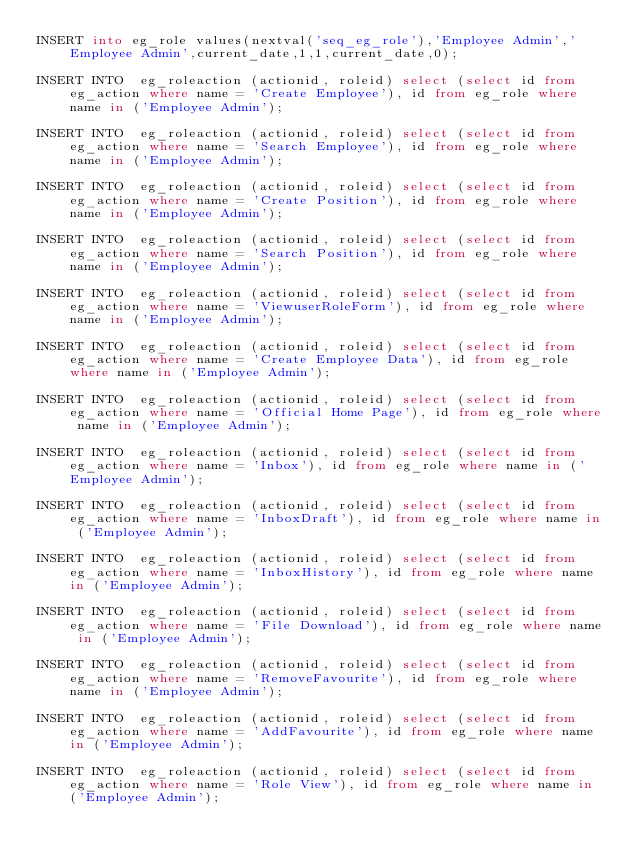<code> <loc_0><loc_0><loc_500><loc_500><_SQL_>INSERT into eg_role values(nextval('seq_eg_role'),'Employee Admin','Employee Admin',current_date,1,1,current_date,0);

INSERT INTO  eg_roleaction (actionid, roleid) select (select id from eg_action where name = 'Create Employee'), id from eg_role where name in ('Employee Admin');

INSERT INTO  eg_roleaction (actionid, roleid) select (select id from eg_action where name = 'Search Employee'), id from eg_role where name in ('Employee Admin');

INSERT INTO  eg_roleaction (actionid, roleid) select (select id from eg_action where name = 'Create Position'), id from eg_role where name in ('Employee Admin');

INSERT INTO  eg_roleaction (actionid, roleid) select (select id from eg_action where name = 'Search Position'), id from eg_role where name in ('Employee Admin');

INSERT INTO  eg_roleaction (actionid, roleid) select (select id from eg_action where name = 'ViewuserRoleForm'), id from eg_role where name in ('Employee Admin');

INSERT INTO  eg_roleaction (actionid, roleid) select (select id from eg_action where name = 'Create Employee Data'), id from eg_role where name in ('Employee Admin');

INSERT INTO  eg_roleaction (actionid, roleid) select (select id from eg_action where name = 'Official Home Page'), id from eg_role where name in ('Employee Admin');

INSERT INTO  eg_roleaction (actionid, roleid) select (select id from eg_action where name = 'Inbox'), id from eg_role where name in ('Employee Admin');

INSERT INTO  eg_roleaction (actionid, roleid) select (select id from eg_action where name = 'InboxDraft'), id from eg_role where name in ('Employee Admin');

INSERT INTO  eg_roleaction (actionid, roleid) select (select id from eg_action where name = 'InboxHistory'), id from eg_role where name in ('Employee Admin');

INSERT INTO  eg_roleaction (actionid, roleid) select (select id from eg_action where name = 'File Download'), id from eg_role where name in ('Employee Admin');

INSERT INTO  eg_roleaction (actionid, roleid) select (select id from eg_action where name = 'RemoveFavourite'), id from eg_role where name in ('Employee Admin');

INSERT INTO  eg_roleaction (actionid, roleid) select (select id from eg_action where name = 'AddFavourite'), id from eg_role where name in ('Employee Admin');

INSERT INTO  eg_roleaction (actionid, roleid) select (select id from eg_action where name = 'Role View'), id from eg_role where name in ('Employee Admin');
</code> 